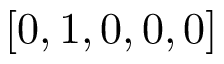<formula> <loc_0><loc_0><loc_500><loc_500>[ 0 , 1 , 0 , 0 , 0 ]</formula> 